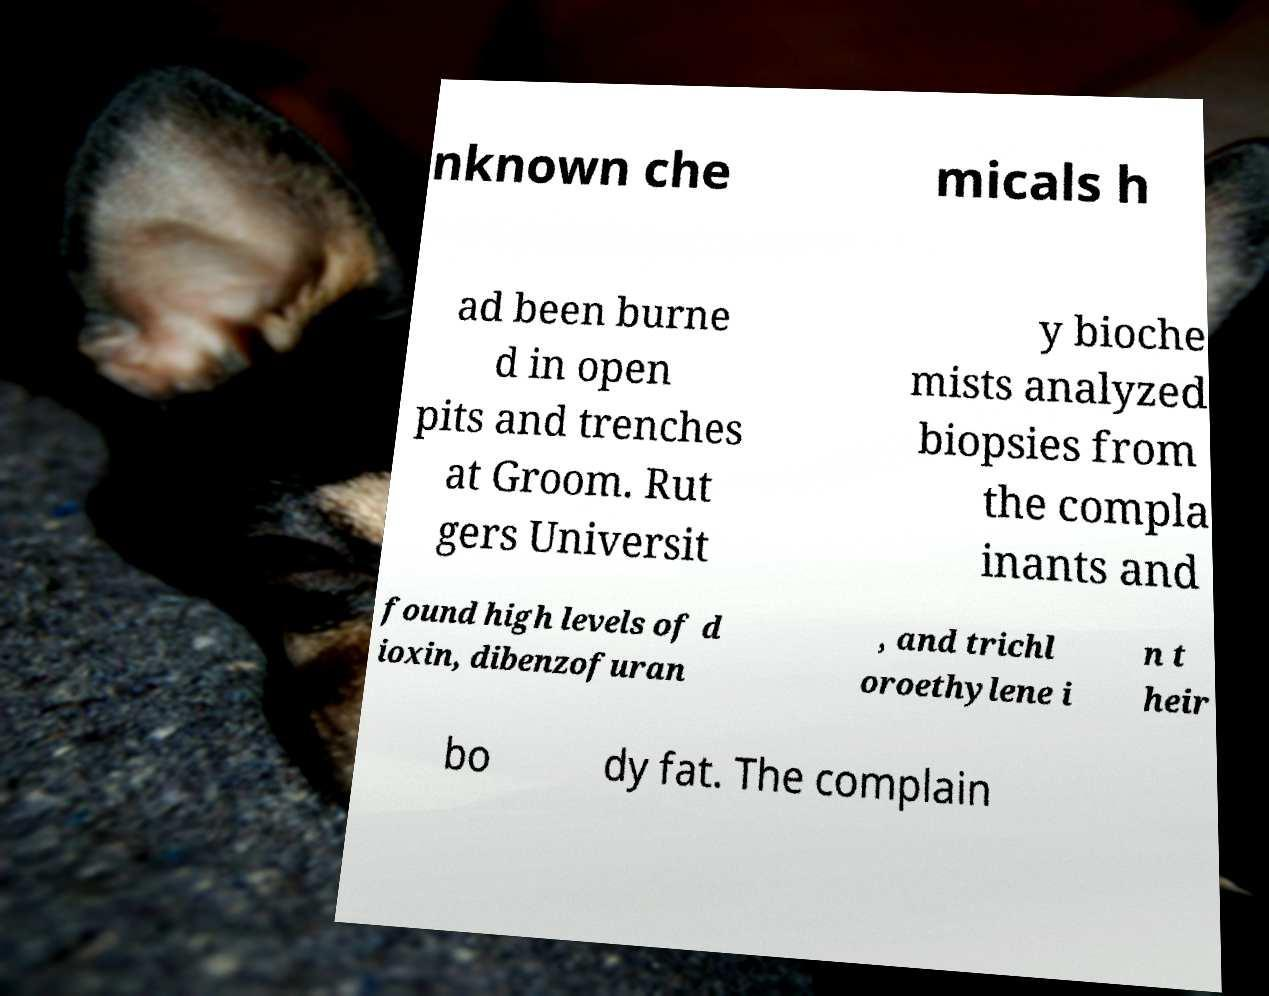Could you extract and type out the text from this image? nknown che micals h ad been burne d in open pits and trenches at Groom. Rut gers Universit y bioche mists analyzed biopsies from the compla inants and found high levels of d ioxin, dibenzofuran , and trichl oroethylene i n t heir bo dy fat. The complain 